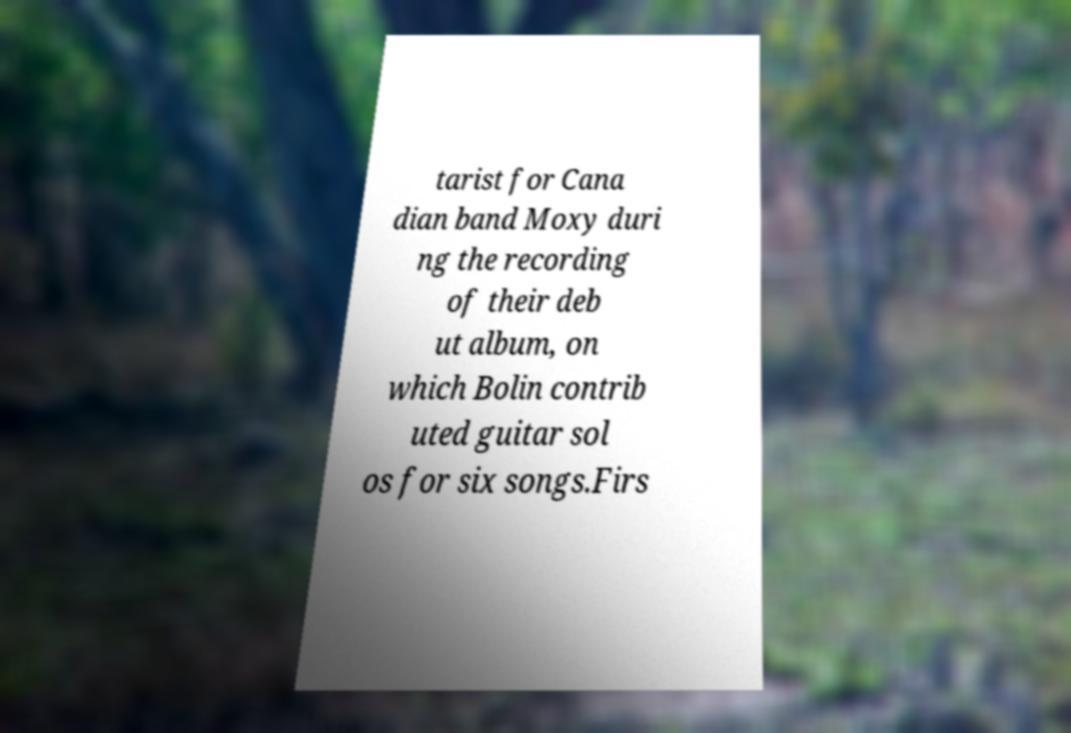I need the written content from this picture converted into text. Can you do that? tarist for Cana dian band Moxy duri ng the recording of their deb ut album, on which Bolin contrib uted guitar sol os for six songs.Firs 